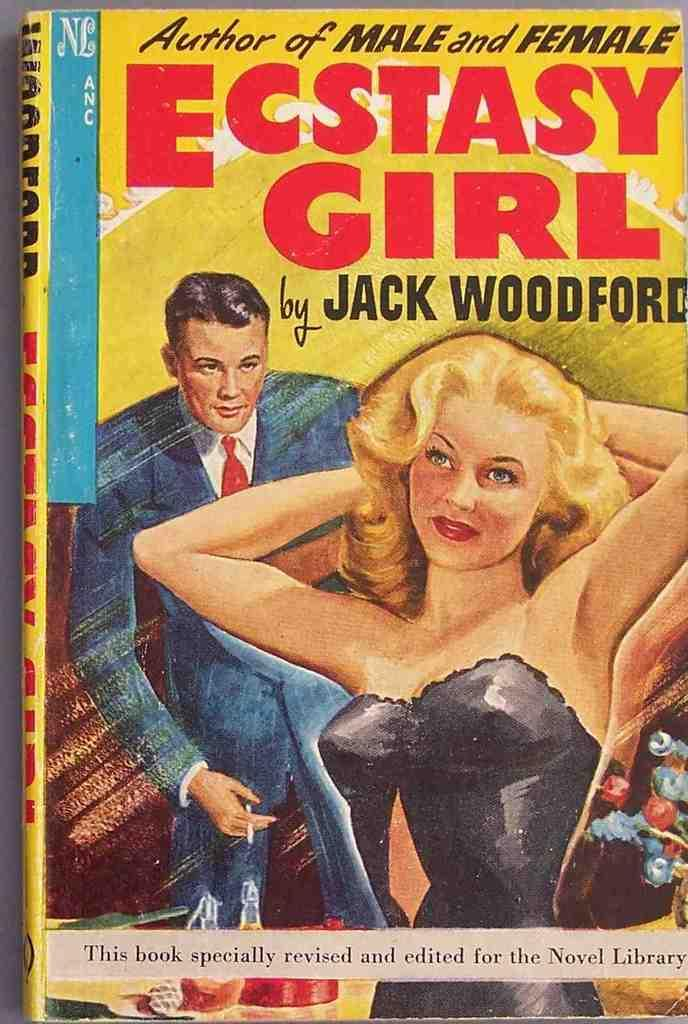<image>
Give a short and clear explanation of the subsequent image. A cover of an older book written by Jack Woodford, portraying a woman and a man. 